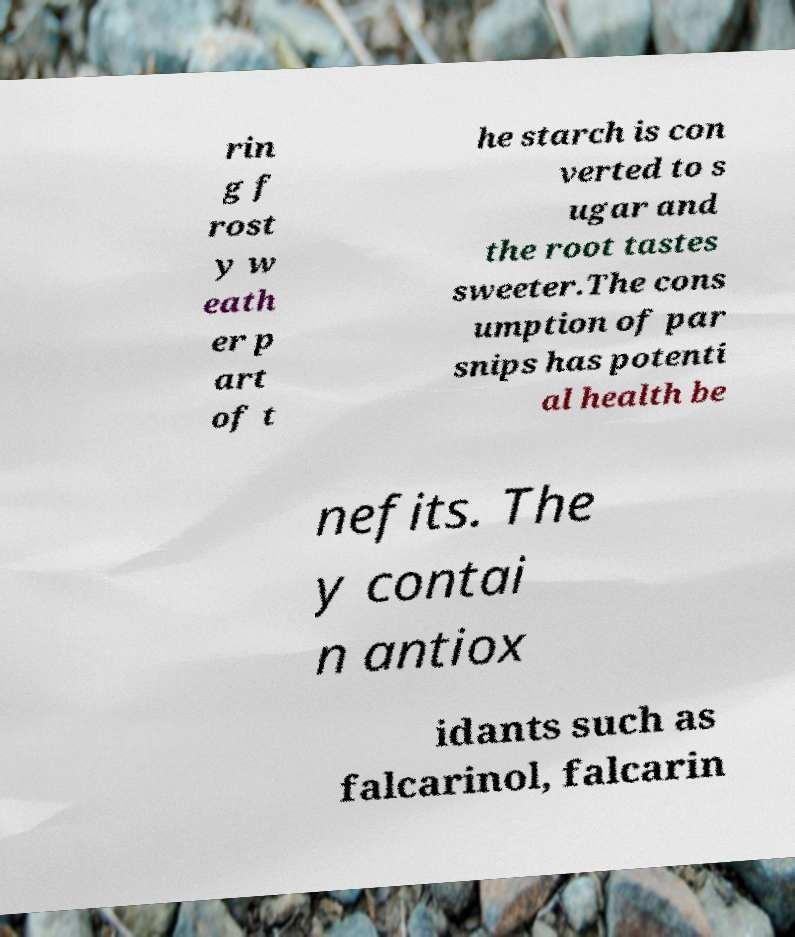For documentation purposes, I need the text within this image transcribed. Could you provide that? rin g f rost y w eath er p art of t he starch is con verted to s ugar and the root tastes sweeter.The cons umption of par snips has potenti al health be nefits. The y contai n antiox idants such as falcarinol, falcarin 